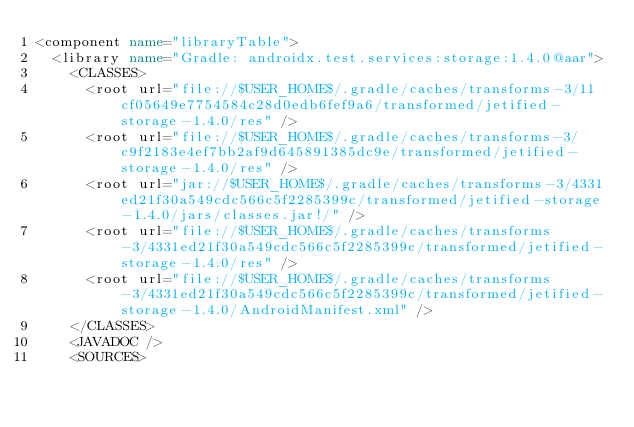Convert code to text. <code><loc_0><loc_0><loc_500><loc_500><_XML_><component name="libraryTable">
  <library name="Gradle: androidx.test.services:storage:1.4.0@aar">
    <CLASSES>
      <root url="file://$USER_HOME$/.gradle/caches/transforms-3/11cf05649e7754584c28d0edb6fef9a6/transformed/jetified-storage-1.4.0/res" />
      <root url="file://$USER_HOME$/.gradle/caches/transforms-3/c9f2183e4ef7bb2af9d645891385dc9e/transformed/jetified-storage-1.4.0/res" />
      <root url="jar://$USER_HOME$/.gradle/caches/transforms-3/4331ed21f30a549cdc566c5f2285399c/transformed/jetified-storage-1.4.0/jars/classes.jar!/" />
      <root url="file://$USER_HOME$/.gradle/caches/transforms-3/4331ed21f30a549cdc566c5f2285399c/transformed/jetified-storage-1.4.0/res" />
      <root url="file://$USER_HOME$/.gradle/caches/transforms-3/4331ed21f30a549cdc566c5f2285399c/transformed/jetified-storage-1.4.0/AndroidManifest.xml" />
    </CLASSES>
    <JAVADOC />
    <SOURCES></code> 